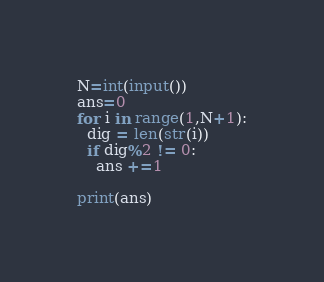Convert code to text. <code><loc_0><loc_0><loc_500><loc_500><_Python_>N=int(input())
ans=0
for i in range(1,N+1):
  dig = len(str(i))
  if dig%2 != 0:
    ans +=1
   
print(ans)
</code> 